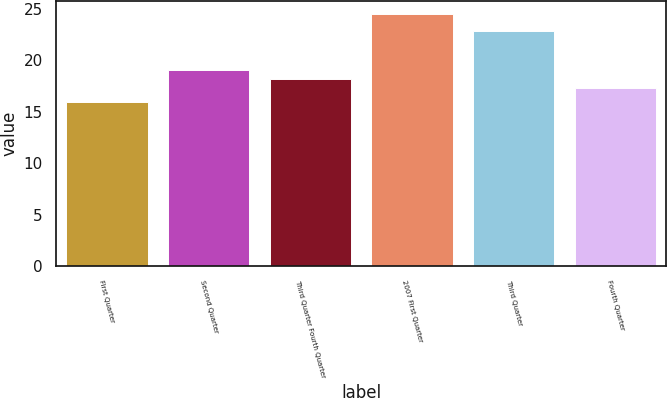Convert chart. <chart><loc_0><loc_0><loc_500><loc_500><bar_chart><fcel>First Quarter<fcel>Second Quarter<fcel>Third Quarter Fourth Quarter<fcel>2007 First Quarter<fcel>Third Quarter<fcel>Fourth Quarter<nl><fcel>15.95<fcel>19.03<fcel>18.17<fcel>24.54<fcel>22.85<fcel>17.31<nl></chart> 